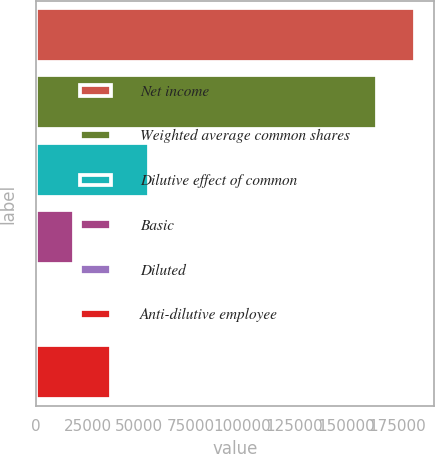<chart> <loc_0><loc_0><loc_500><loc_500><bar_chart><fcel>Net income<fcel>Weighted average common shares<fcel>Dilutive effect of common<fcel>Basic<fcel>Diluted<fcel>Anti-dilutive employee<nl><fcel>183367<fcel>165127<fcel>54721.4<fcel>18241.3<fcel>1.21<fcel>36481.4<nl></chart> 